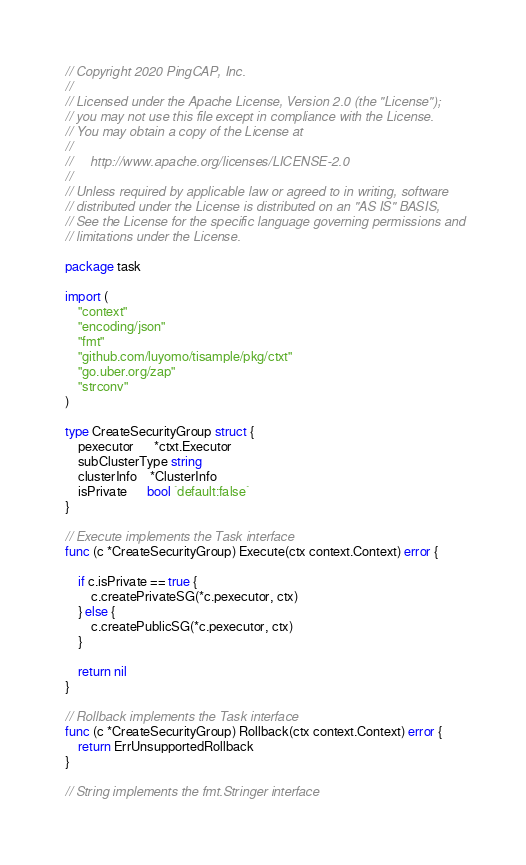<code> <loc_0><loc_0><loc_500><loc_500><_Go_>// Copyright 2020 PingCAP, Inc.
//
// Licensed under the Apache License, Version 2.0 (the "License");
// you may not use this file except in compliance with the License.
// You may obtain a copy of the License at
//
//     http://www.apache.org/licenses/LICENSE-2.0
//
// Unless required by applicable law or agreed to in writing, software
// distributed under the License is distributed on an "AS IS" BASIS,
// See the License for the specific language governing permissions and
// limitations under the License.

package task

import (
	"context"
	"encoding/json"
	"fmt"
	"github.com/luyomo/tisample/pkg/ctxt"
	"go.uber.org/zap"
	"strconv"
)

type CreateSecurityGroup struct {
	pexecutor      *ctxt.Executor
	subClusterType string
	clusterInfo    *ClusterInfo
	isPrivate      bool `default:false`
}

// Execute implements the Task interface
func (c *CreateSecurityGroup) Execute(ctx context.Context) error {

	if c.isPrivate == true {
		c.createPrivateSG(*c.pexecutor, ctx)
	} else {
		c.createPublicSG(*c.pexecutor, ctx)
	}

	return nil
}

// Rollback implements the Task interface
func (c *CreateSecurityGroup) Rollback(ctx context.Context) error {
	return ErrUnsupportedRollback
}

// String implements the fmt.Stringer interface</code> 